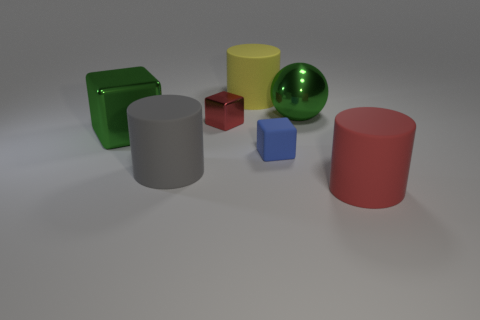There is a red thing that is on the left side of the tiny object in front of the red thing that is behind the red cylinder; what size is it?
Ensure brevity in your answer.  Small. How many other objects are the same color as the small matte cube?
Your answer should be very brief. 0. What shape is the green metal object that is the same size as the green sphere?
Your response must be concise. Cube. There is a green object that is right of the red cube; how big is it?
Ensure brevity in your answer.  Large. Is the color of the cube that is left of the gray rubber thing the same as the rubber cylinder on the right side of the yellow rubber cylinder?
Offer a terse response. No. The small object right of the big matte cylinder that is behind the big shiny object that is behind the tiny shiny object is made of what material?
Offer a terse response. Rubber. Is there a gray cylinder of the same size as the red cylinder?
Give a very brief answer. Yes. There is a red cylinder that is the same size as the gray object; what is it made of?
Offer a terse response. Rubber. There is a thing behind the green sphere; what is its shape?
Provide a short and direct response. Cylinder. Do the green thing in front of the metallic ball and the large cylinder that is on the right side of the large sphere have the same material?
Offer a terse response. No. 